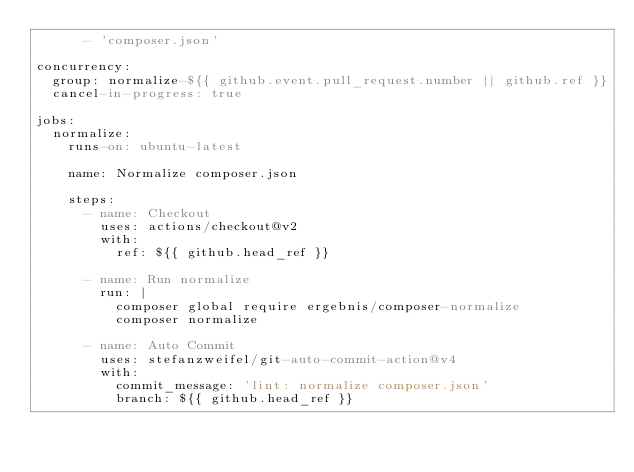Convert code to text. <code><loc_0><loc_0><loc_500><loc_500><_YAML_>      - 'composer.json'

concurrency:
  group: normalize-${{ github.event.pull_request.number || github.ref }}
  cancel-in-progress: true

jobs:
  normalize:
    runs-on: ubuntu-latest

    name: Normalize composer.json

    steps:
      - name: Checkout
        uses: actions/checkout@v2
        with:
          ref: ${{ github.head_ref }}

      - name: Run normalize
        run: |
          composer global require ergebnis/composer-normalize
          composer normalize

      - name: Auto Commit
        uses: stefanzweifel/git-auto-commit-action@v4
        with:
          commit_message: 'lint: normalize composer.json'
          branch: ${{ github.head_ref }}
</code> 